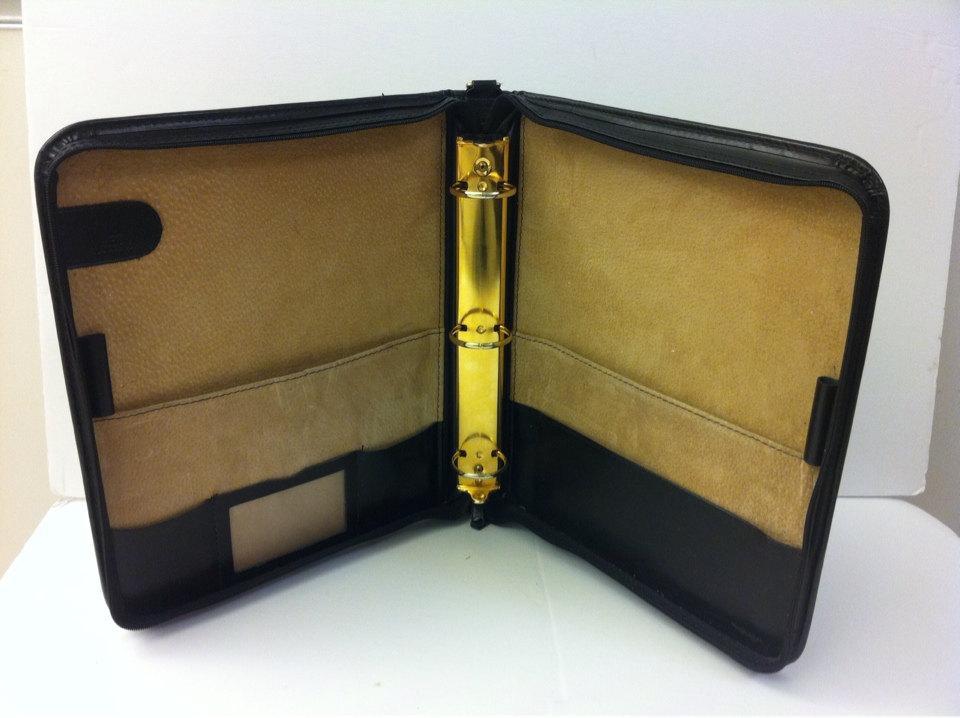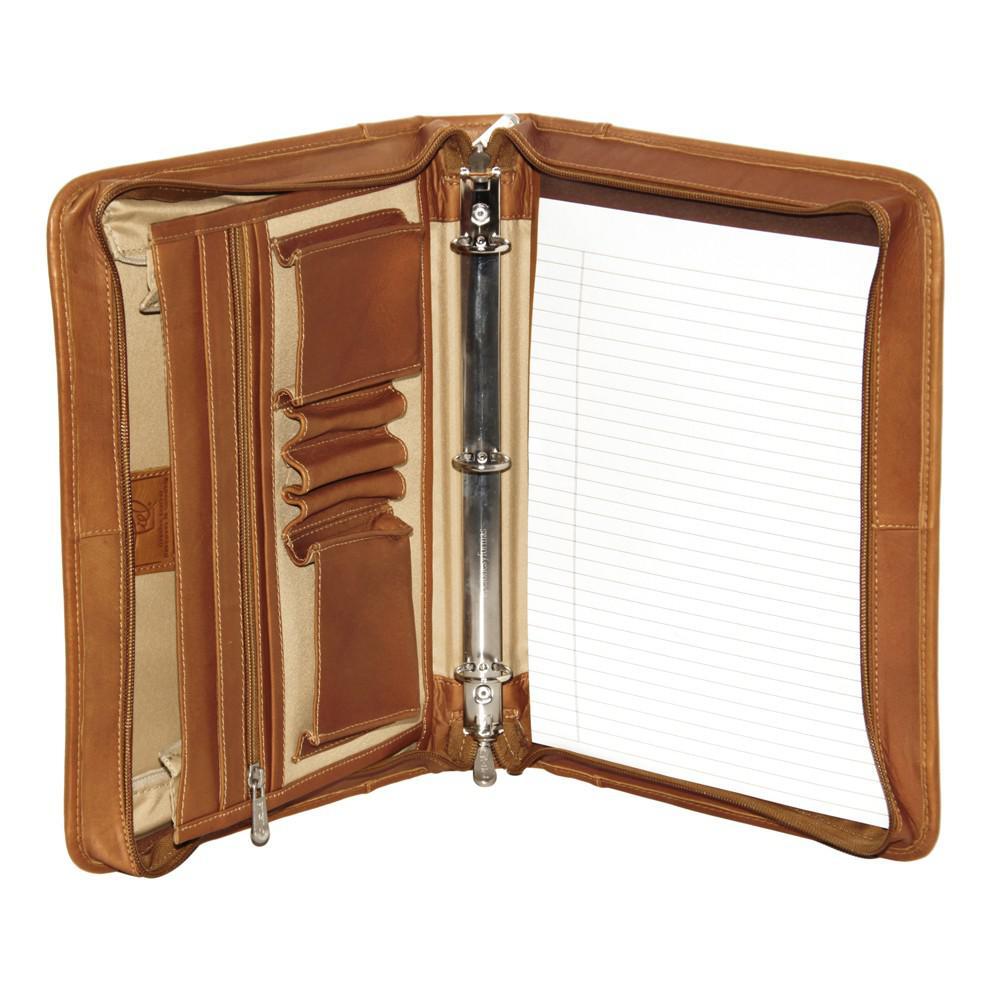The first image is the image on the left, the second image is the image on the right. Assess this claim about the two images: "there are two open planners in the image pair". Correct or not? Answer yes or no. Yes. The first image is the image on the left, the second image is the image on the right. Assess this claim about the two images: "There is an example of a closed binder.". Correct or not? Answer yes or no. No. 